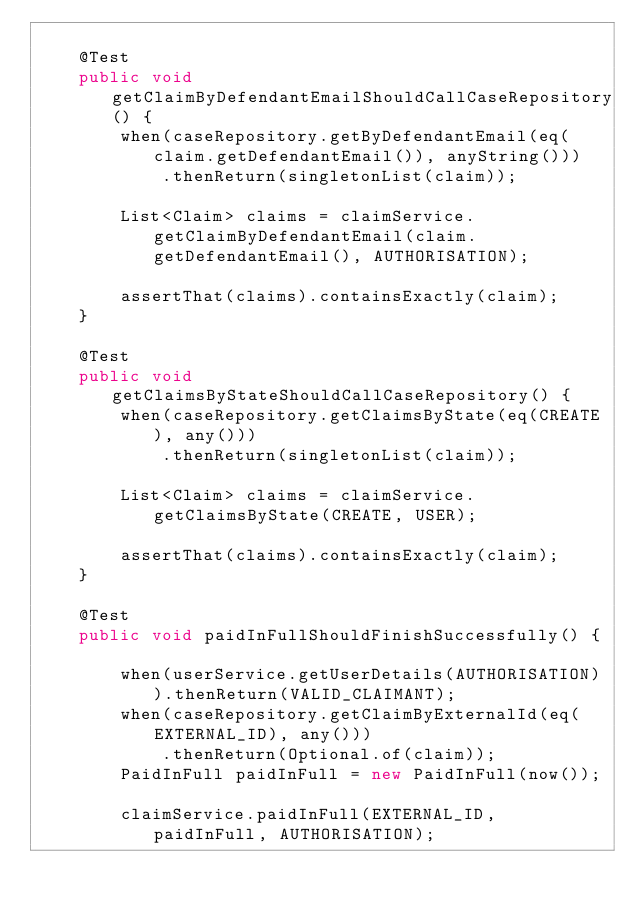Convert code to text. <code><loc_0><loc_0><loc_500><loc_500><_Java_>
    @Test
    public void getClaimByDefendantEmailShouldCallCaseRepository() {
        when(caseRepository.getByDefendantEmail(eq(claim.getDefendantEmail()), anyString()))
            .thenReturn(singletonList(claim));

        List<Claim> claims = claimService.getClaimByDefendantEmail(claim.getDefendantEmail(), AUTHORISATION);

        assertThat(claims).containsExactly(claim);
    }

    @Test
    public void getClaimsByStateShouldCallCaseRepository() {
        when(caseRepository.getClaimsByState(eq(CREATE), any()))
            .thenReturn(singletonList(claim));

        List<Claim> claims = claimService.getClaimsByState(CREATE, USER);

        assertThat(claims).containsExactly(claim);
    }

    @Test
    public void paidInFullShouldFinishSuccessfully() {

        when(userService.getUserDetails(AUTHORISATION)).thenReturn(VALID_CLAIMANT);
        when(caseRepository.getClaimByExternalId(eq(EXTERNAL_ID), any()))
            .thenReturn(Optional.of(claim));
        PaidInFull paidInFull = new PaidInFull(now());

        claimService.paidInFull(EXTERNAL_ID, paidInFull, AUTHORISATION);
</code> 